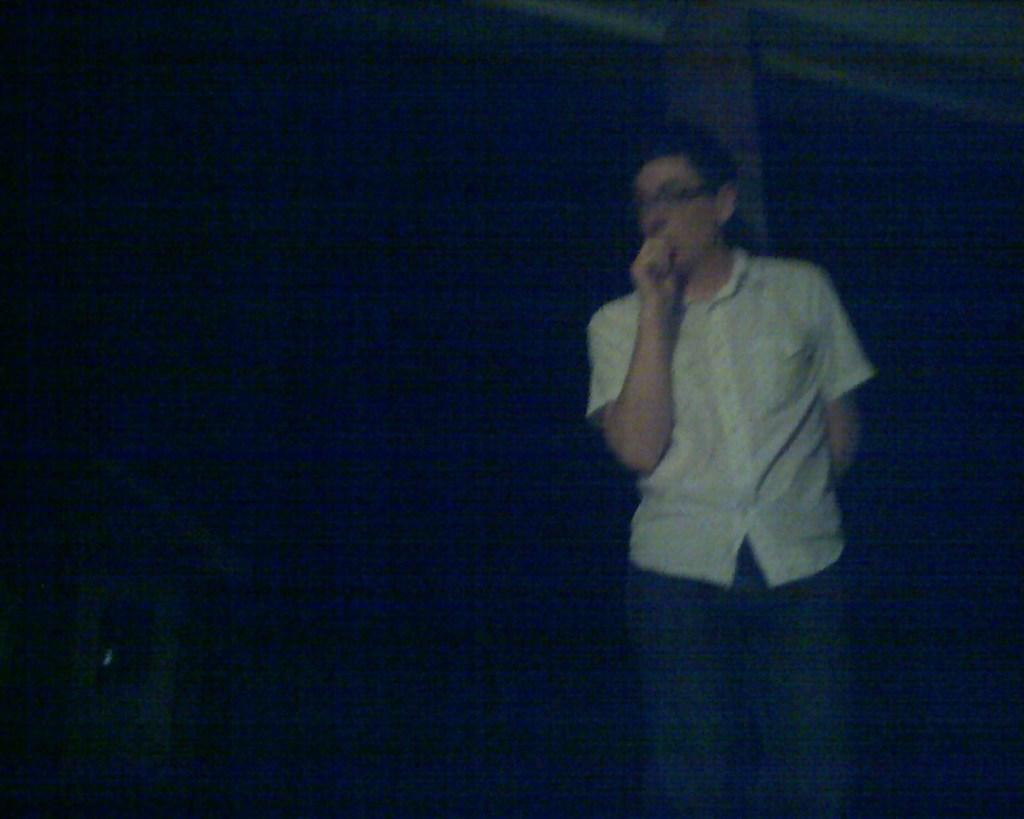Who is the main subject in the image? There is a man in the image. What is the man wearing? The man is wearing a white shirt. Where is the man positioned in the image? The man is standing in the front of the image. What can be observed about the background of the image? The background of the image is dark. What type of teeth can be seen in the image? There are no teeth visible in the image, as it features a man standing in a dark background. What kind of sticks are being used by the man in the image? There are no sticks present in the image; the man is simply standing in a white shirt. 